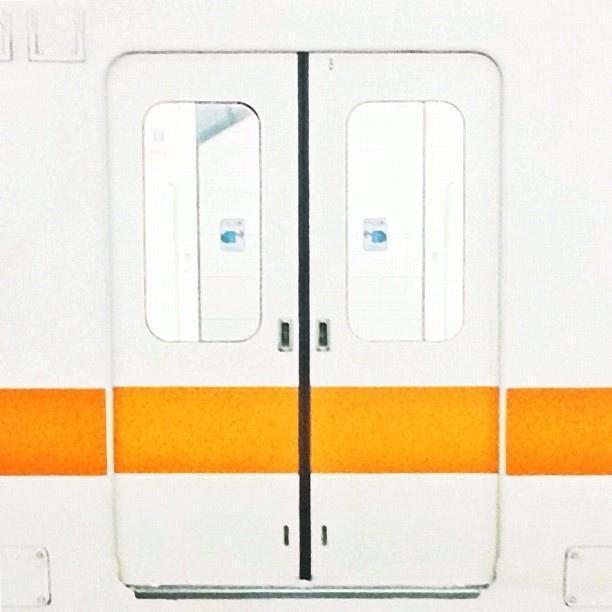How many yellow stripes are in this picture?
Give a very brief answer. 1. How many trains are in the photo?
Give a very brief answer. 1. 